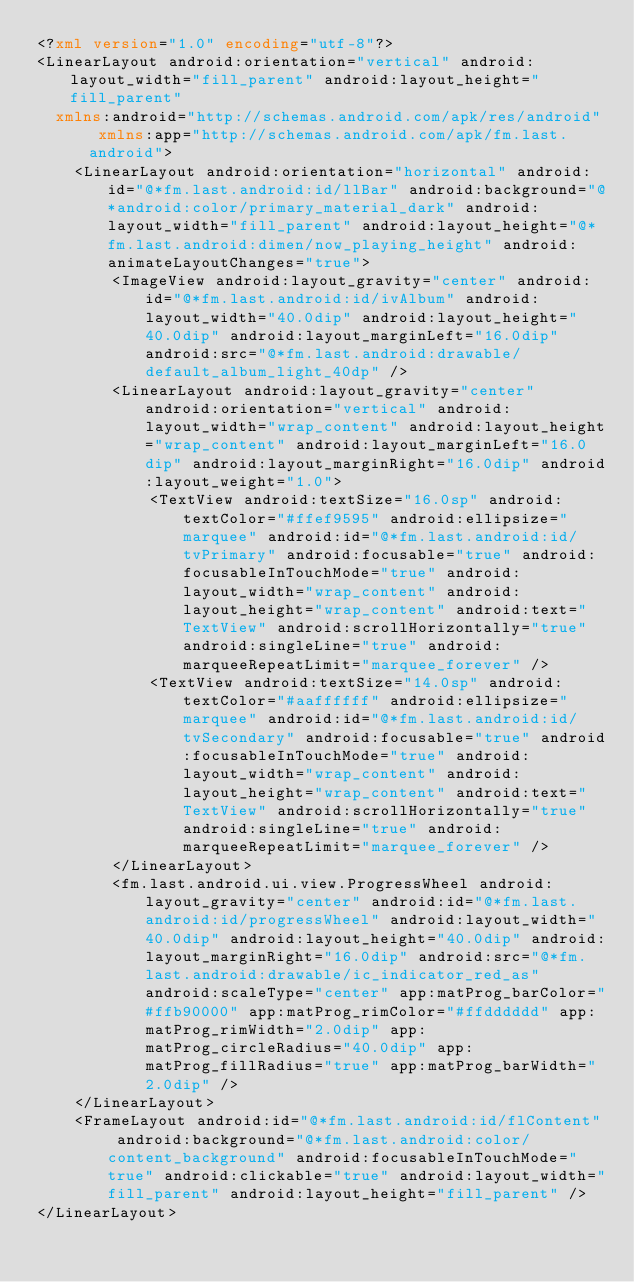Convert code to text. <code><loc_0><loc_0><loc_500><loc_500><_XML_><?xml version="1.0" encoding="utf-8"?>
<LinearLayout android:orientation="vertical" android:layout_width="fill_parent" android:layout_height="fill_parent"
  xmlns:android="http://schemas.android.com/apk/res/android" xmlns:app="http://schemas.android.com/apk/fm.last.android">
    <LinearLayout android:orientation="horizontal" android:id="@*fm.last.android:id/llBar" android:background="@*android:color/primary_material_dark" android:layout_width="fill_parent" android:layout_height="@*fm.last.android:dimen/now_playing_height" android:animateLayoutChanges="true">
        <ImageView android:layout_gravity="center" android:id="@*fm.last.android:id/ivAlbum" android:layout_width="40.0dip" android:layout_height="40.0dip" android:layout_marginLeft="16.0dip" android:src="@*fm.last.android:drawable/default_album_light_40dp" />
        <LinearLayout android:layout_gravity="center" android:orientation="vertical" android:layout_width="wrap_content" android:layout_height="wrap_content" android:layout_marginLeft="16.0dip" android:layout_marginRight="16.0dip" android:layout_weight="1.0">
            <TextView android:textSize="16.0sp" android:textColor="#ffef9595" android:ellipsize="marquee" android:id="@*fm.last.android:id/tvPrimary" android:focusable="true" android:focusableInTouchMode="true" android:layout_width="wrap_content" android:layout_height="wrap_content" android:text="TextView" android:scrollHorizontally="true" android:singleLine="true" android:marqueeRepeatLimit="marquee_forever" />
            <TextView android:textSize="14.0sp" android:textColor="#aaffffff" android:ellipsize="marquee" android:id="@*fm.last.android:id/tvSecondary" android:focusable="true" android:focusableInTouchMode="true" android:layout_width="wrap_content" android:layout_height="wrap_content" android:text="TextView" android:scrollHorizontally="true" android:singleLine="true" android:marqueeRepeatLimit="marquee_forever" />
        </LinearLayout>
        <fm.last.android.ui.view.ProgressWheel android:layout_gravity="center" android:id="@*fm.last.android:id/progressWheel" android:layout_width="40.0dip" android:layout_height="40.0dip" android:layout_marginRight="16.0dip" android:src="@*fm.last.android:drawable/ic_indicator_red_as" android:scaleType="center" app:matProg_barColor="#ffb90000" app:matProg_rimColor="#ffdddddd" app:matProg_rimWidth="2.0dip" app:matProg_circleRadius="40.0dip" app:matProg_fillRadius="true" app:matProg_barWidth="2.0dip" />
    </LinearLayout>
    <FrameLayout android:id="@*fm.last.android:id/flContent" android:background="@*fm.last.android:color/content_background" android:focusableInTouchMode="true" android:clickable="true" android:layout_width="fill_parent" android:layout_height="fill_parent" />
</LinearLayout></code> 